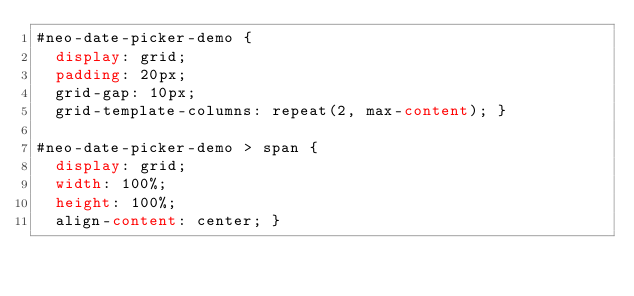Convert code to text. <code><loc_0><loc_0><loc_500><loc_500><_CSS_>#neo-date-picker-demo {
	display: grid;
	padding: 20px;
	grid-gap: 10px;
	grid-template-columns: repeat(2, max-content); }

#neo-date-picker-demo > span {
	display: grid;
	width: 100%;
	height: 100%;
	align-content: center; }
</code> 